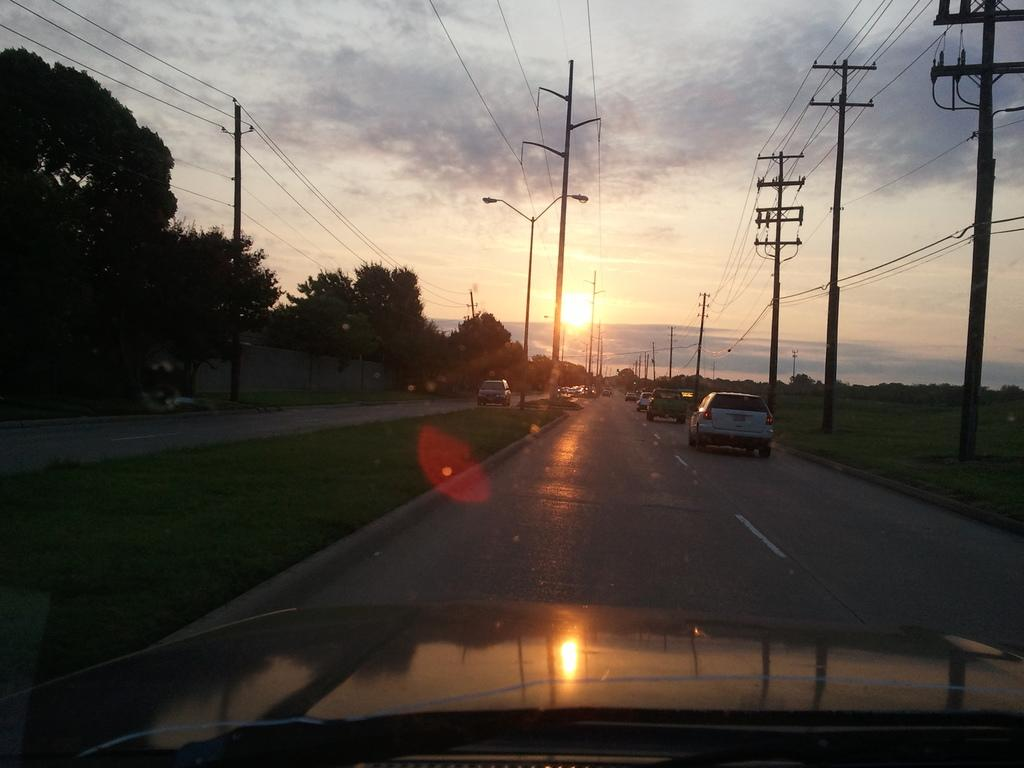What can be seen on the road in the image? There are vehicles on the road in the image. What type of vegetation is present in the image? There are trees and grass in the image. What structures can be seen in the image? There is a wall, street lights, and current poles in the image. What part of the natural environment is visible in the image? The sky is visible in the background of the image. What type of bread can be seen hanging from the trees in the image? There is no bread present in the image; it features trees, grass, vehicles, a wall, street lights, and current poles. What type of scarf is draped over the current poles in the image? There is no scarf present in the image; it features trees, grass, vehicles, a wall, street lights, and current poles. 